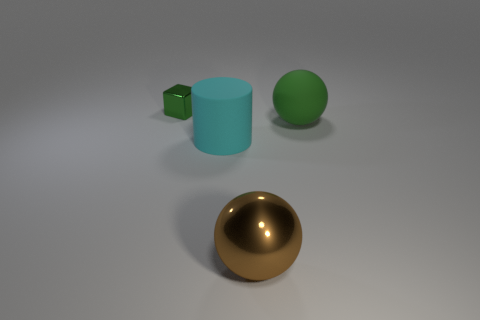Are the large cyan cylinder and the brown sphere made of the same material?
Your response must be concise. No. The metallic object behind the metal sphere has what shape?
Make the answer very short. Cube. There is a shiny thing to the right of the shiny block; are there any brown balls that are in front of it?
Your answer should be very brief. No. Are there any gray rubber things that have the same size as the brown metal thing?
Provide a short and direct response. No. There is a metallic block behind the big matte sphere; does it have the same color as the big metallic object?
Keep it short and to the point. No. What is the size of the green block?
Provide a succinct answer. Small. What is the size of the green thing to the right of the green thing on the left side of the big green matte object?
Offer a terse response. Large. How many matte objects have the same color as the tiny metal block?
Provide a succinct answer. 1. What number of rubber spheres are there?
Your answer should be compact. 1. What number of other big objects have the same material as the big cyan object?
Offer a terse response. 1. 